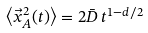<formula> <loc_0><loc_0><loc_500><loc_500>\left \langle \vec { x } _ { A } ^ { 2 } ( t ) \right \rangle = 2 \bar { D } \, t ^ { 1 - d / 2 }</formula> 